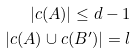Convert formula to latex. <formula><loc_0><loc_0><loc_500><loc_500>| c ( A ) | \leq d - 1 \\ | c ( A ) \cup c ( B ^ { \prime } ) | = l</formula> 